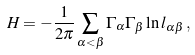<formula> <loc_0><loc_0><loc_500><loc_500>H = - \frac { 1 } { 2 \pi } \sum _ { \alpha < \beta } \Gamma _ { \alpha } \Gamma _ { \beta } \ln l _ { \alpha \beta } \, ,</formula> 